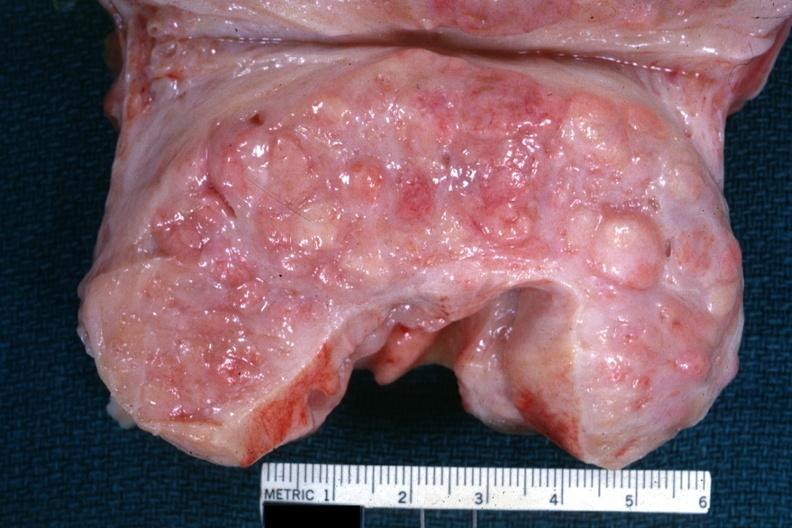what cut surface with nodular hyperplasia?
Answer the question using a single word or phrase. Excellent example 